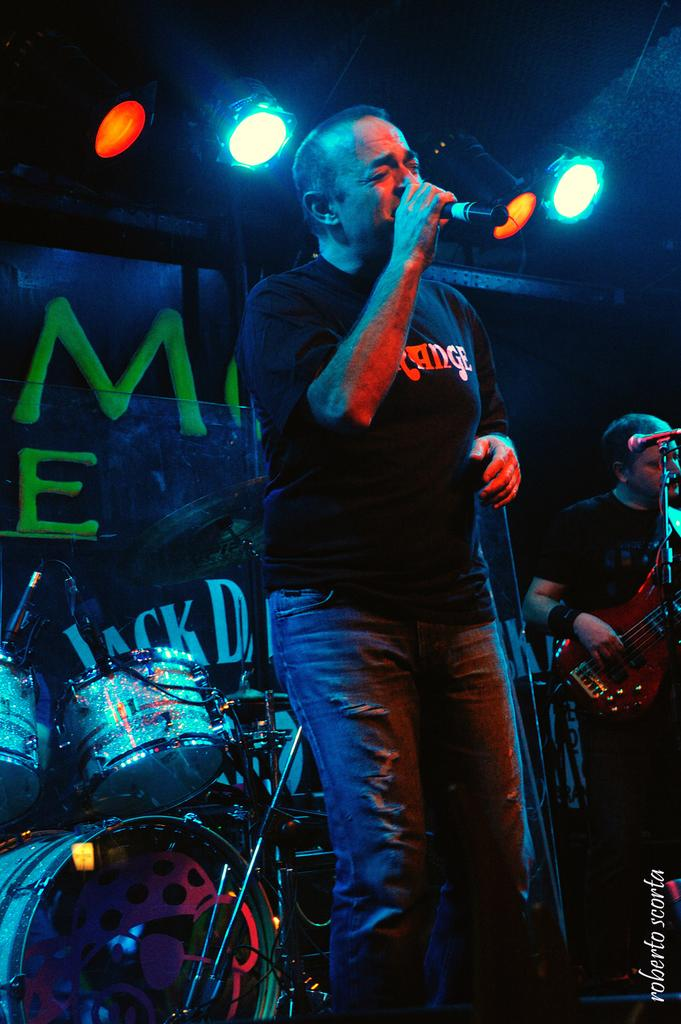What is the person in the foreground of the image doing? The person is holding a mic and singing. What musical instrument can be seen in the background of the image? There is a drum set in the background. What is hanging in the background of the image? There is a banner in the background. What can be seen illuminating the scene in the background? There are lights in the background. What other musician is present in the background of the image? There is a person playing a guitar in the background. What substance is the person holding the mic using to enhance their performance? There is no indication of any substance being used in the image. 